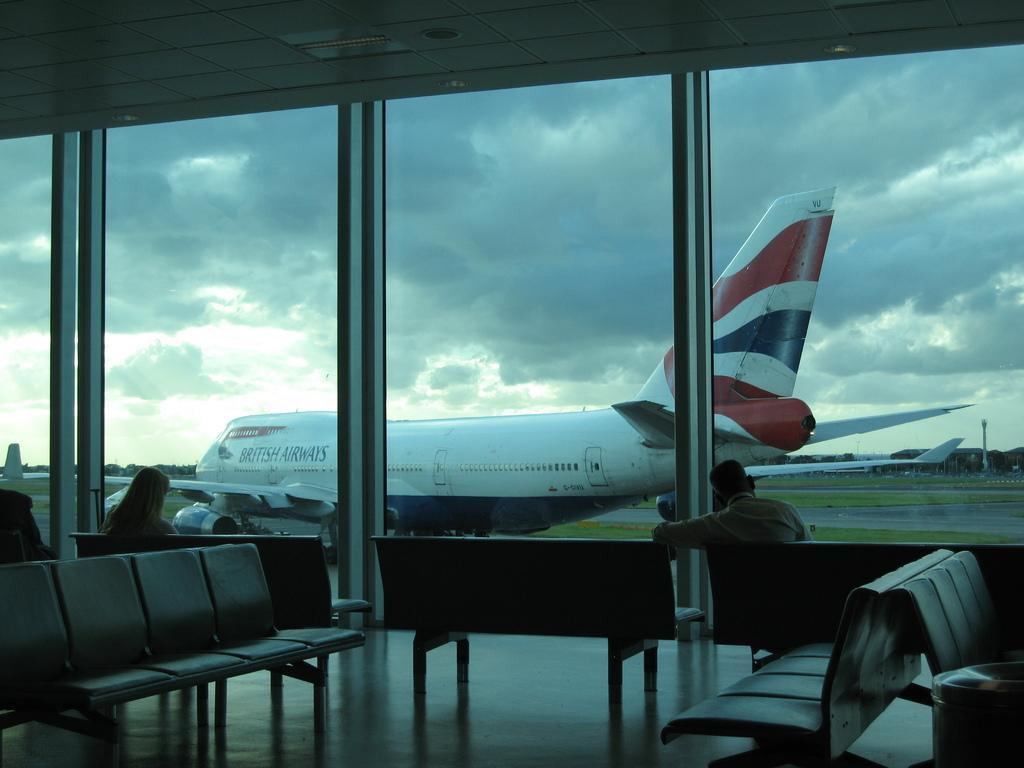Please provide a concise description of this image. As we can see in the image there are chairs, two people sitting over here, grass, plane and clouds. The image is little dark. 